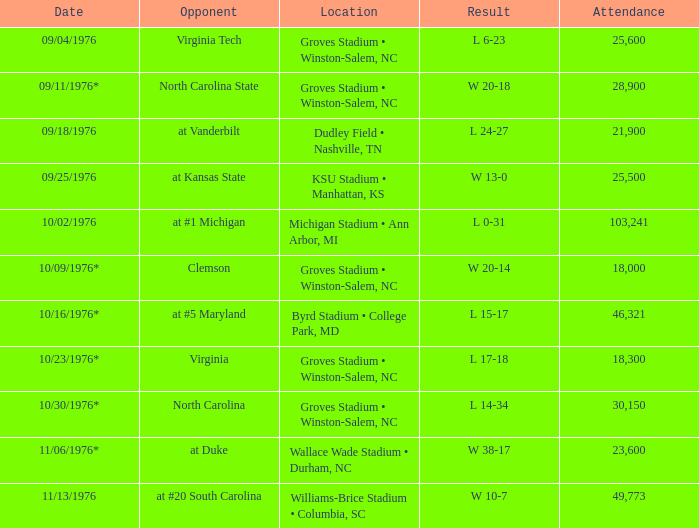On what date did the contest against north carolina take place? 10/30/1976*. 